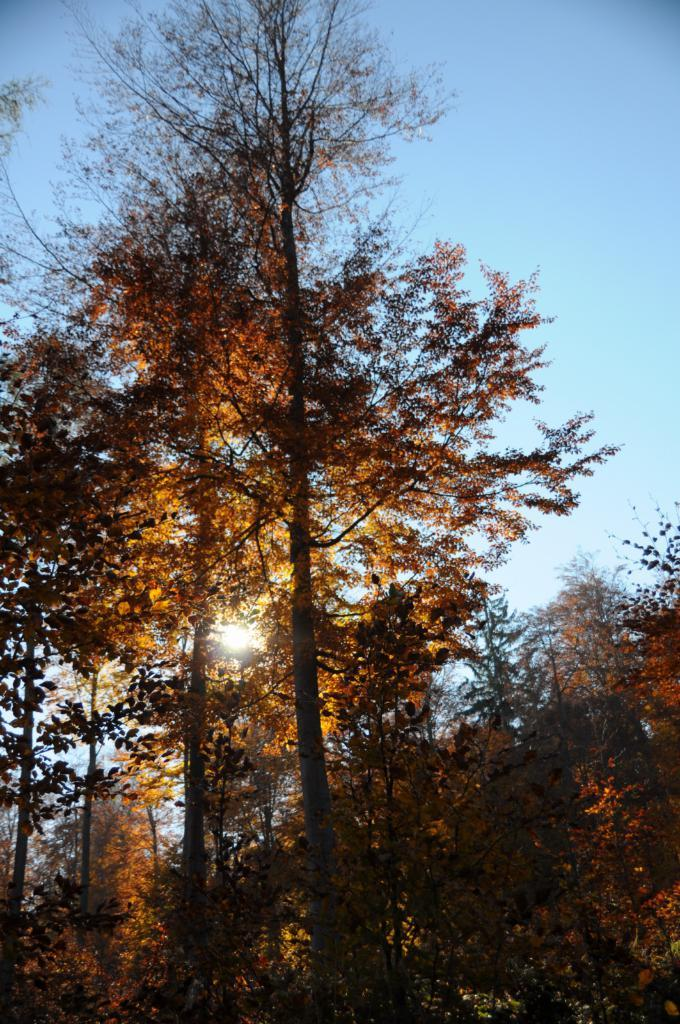What type of vegetation can be seen in the image? There are trees in the image. Where are the trees located in relation to the image? The trees are in the foreground of the image. What can be seen in the background of the image? The sky is visible in the background of the image. What is the condition of the sky in the image? The sky is clear in the image. What type of polish is being advertised on the trees in the image? There is no advertisement or polish present in the image; it features trees and a clear sky. What kind of brush is visible in the image? There is no brush present in the image. 